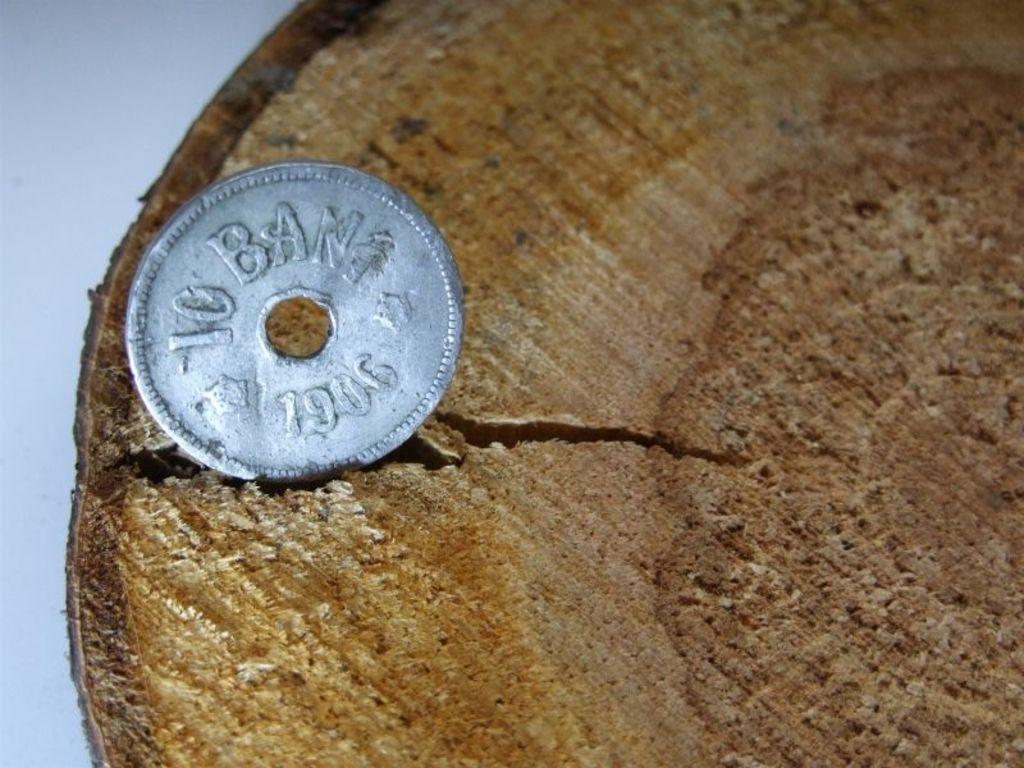<image>
Provide a brief description of the given image. a silver coin on a wooden surface that says 10 ban 1906 